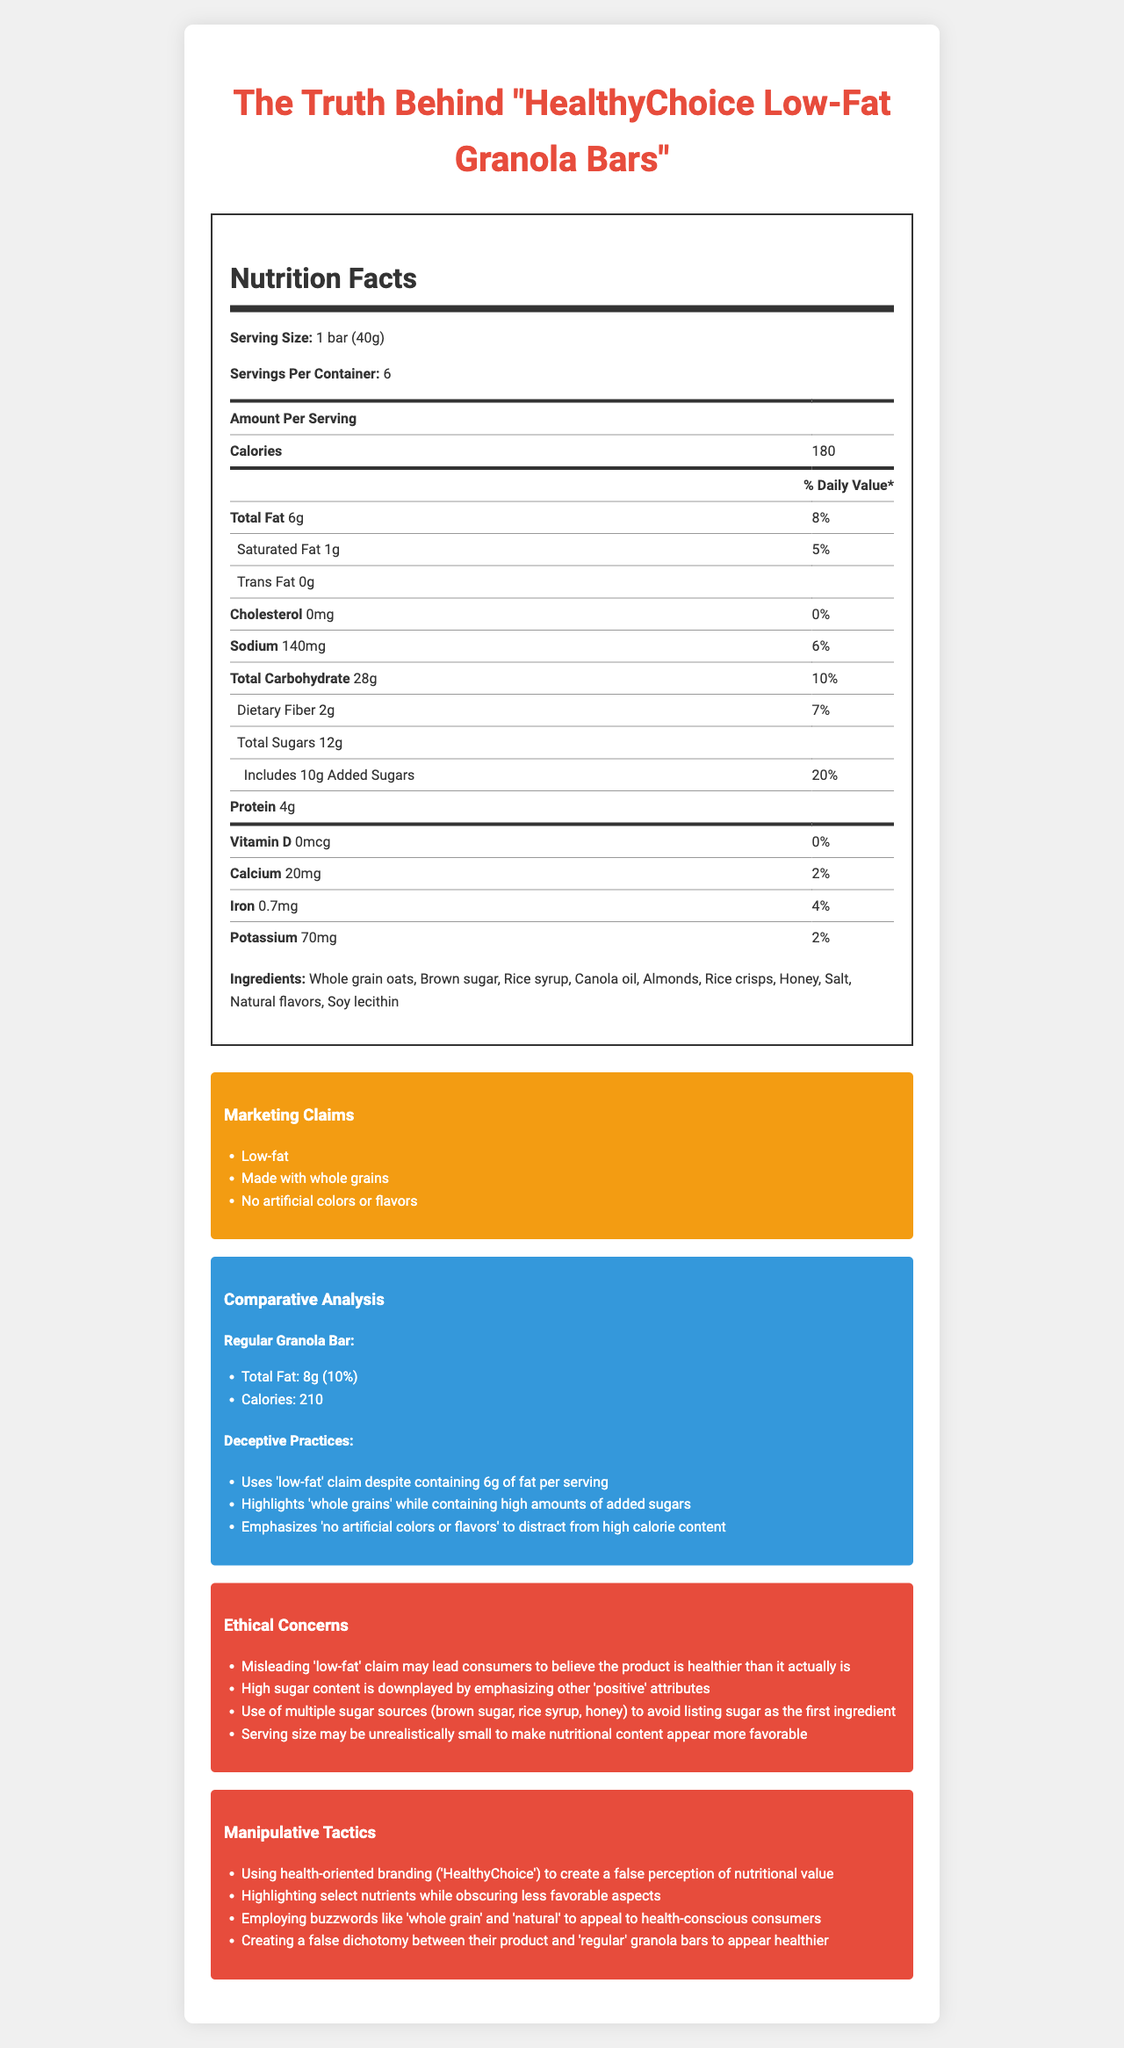what is the serving size for "HealthyChoice Low-Fat Granola Bars"? The serving size is listed at the beginning of the Nutrition Facts section as "1 bar (40g)".
Answer: 1 bar (40g) how many servings are there per container? The number of servings per container is specified as 6 in the Nutrition Facts section.
Answer: 6 what is the total fat content per serving? The document specifies that each serving contains 6 grams of total fat in the Nutrition Facts section.
Answer: 6g what percentage of the daily value does the added sugars represent? The document lists the added sugars as having a daily value of 20% in the Nutrition Facts section.
Answer: 20% how much protein does one bar contain? According to the Nutrition Facts section, each bar contains 4 grams of protein.
Answer: 4g which ingredient is listed first in the ingredients list? The first ingredient in the ingredients list is Whole grain oats.
Answer: Whole grain oats what deceptive practice is used regarding the "low-fat" claim? A. It contains trans fat B. The serving size is large C. It contains 6g of fat per serving D. It has artificial colors C is correct because the document states that the "low-fat" claim is deceptive since the product contains 6g of fat per serving.
Answer: C which of the following is a manipulative tactic used by "HealthyChoice"? I. Highlighting select nutrients while obscuring less favorable aspects II. Promoting the product as sugar-free III. Using health-oriented branding IV. Emphasizing artificial ingredients The document notes manipulative tactics like highlighting select nutrients while obscuring others (I) and using health-oriented branding ('HealthyChoice') (III).
Answer: I and III is the cholesterol content in "HealthyChoice Low-Fat Granola Bars" significant? The cholesterol content in the granola bars is listed as 0mg with a daily value of 0%, indicating it is not significant.
Answer: No summarize the main idea of this Nutrition Facts Label document. This summary combines the nutritional content, marketing claims, comparative analysis, deceptive practices, ethical concerns, and manipulative tactics discussed in the document.
Answer: The document analyzes the Nutrition Facts label of "HealthyChoice Low-Fat Granola Bars," highlighting the manipulative tactics and ethical concerns associated with the misleading "low-fat" claim and high sugar content, while using health-oriented marketing to disguise less favorable aspects. how much more fat does a regular granola bar have compared to "HealthyChoice Low-Fat Granola Bars"? According to the comparative analysis, regular granola bars have 8g of fat compared to 6g in "HealthyChoice Low-Fat Granola Bars", resulting in a difference of 2g.
Answer: 2g which of the following is not an ingredient in "HealthyChoice Low-Fat Granola Bars"? A. Almonds B. Honey C. Artificial flavors D. Soy lecithin The document lists the ingredients, excluding artificial flavors while Soy lecithin, Almonds, and Honey are included.
Answer: C does the product contain any vitamin D? Vitamin D content is listed as 0mcg with a daily value of 0%, indicating that the product does not contain any vitamin D.
Answer: No what is the main strategy used to avoid listing sugar as the first ingredient? The document states that multiple sources of sugar (brown sugar, rice syrup, honey) are utilized to avoid listing sugar as the first ingredient.
Answer: Use of multiple sugar sources how does the calorie content of "HealthyChoice Low-Fat Granola Bars" compare to regular granola bars? "HealthyChoice Low-Fat Granola Bars" contain 180 calories compared to 210 calories in regular granola bars, which is 30 calories less.
Answer: 30 calories less how much calcium is in one bar of "HealthyChoice Low-Fat Granola Bars"? The Nutrition Facts section lists the calcium content as 20mg per bar.
Answer: 20mg what is the difference in daily value percentage between total fat and saturated fat? Total fat has a daily value of 8%, while saturated fat has a daily value of 5%, making the difference 3%.
Answer: 3% how much potassium does one granola bar contain? The Nutrition Facts label states that one granola bar contains 70mg of potassium.
Answer: 70mg why is the "HealthyChoice" branding considered manipulative? The document highlights manipulative tactics, including using health-oriented branding ("HealthyChoice") to create a false perception of nutritional value.
Answer: It creates a false perception of nutritional value. 